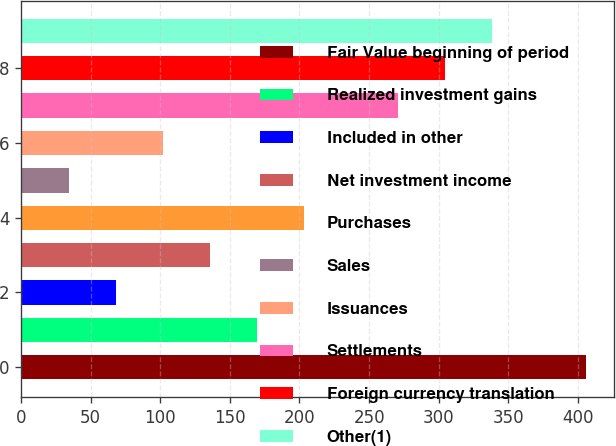Convert chart. <chart><loc_0><loc_0><loc_500><loc_500><bar_chart><fcel>Fair Value beginning of period<fcel>Realized investment gains<fcel>Included in other<fcel>Net investment income<fcel>Purchases<fcel>Sales<fcel>Issuances<fcel>Settlements<fcel>Foreign currency translation<fcel>Other(1)<nl><fcel>405.51<fcel>169.33<fcel>68.11<fcel>135.59<fcel>203.07<fcel>34.37<fcel>101.85<fcel>270.55<fcel>304.29<fcel>338.03<nl></chart> 